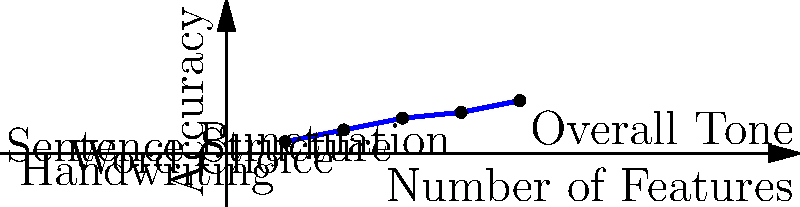As an aspiring indie author, you're developing a sentiment analysis model for handwritten book reviews. The graph shows the accuracy of your model as you add different features. Which feature, when added, results in the most significant improvement in accuracy, and what might this suggest about the importance of certain elements in handwritten reviews? To answer this question, we need to analyze the graph step-by-step:

1. The x-axis represents the number of features added to the sentiment analysis model.
2. The y-axis represents the accuracy of the model.
3. Each point on the graph represents a feature:
   (1, 0.2) - Handwriting
   (2, 0.4) - Word Choice
   (3, 0.6) - Sentence Structure
   (4, 0.7) - Punctuation
   (5, 0.9) - Overall Tone

4. To find the feature that results in the most significant improvement, we need to calculate the increase in accuracy between each point:
   Handwriting to Word Choice: 0.4 - 0.2 = 0.2
   Word Choice to Sentence Structure: 0.6 - 0.4 = 0.2
   Sentence Structure to Punctuation: 0.7 - 0.6 = 0.1
   Punctuation to Overall Tone: 0.9 - 0.7 = 0.2

5. The largest increase is 0.2, which occurs three times. However, the question asks for the most significant improvement, so we should consider which of these 0.2 increases is most impactful.

6. The increase from Handwriting to Word Choice (0.2 to 0.4) doubles the accuracy, making it the most significant improvement.

This suggests that word choice is a crucial element in determining the sentiment of handwritten book reviews. As an aspiring author, this implies that readers pay close attention to the specific words used in reviews, which can greatly influence their overall sentiment.
Answer: Word Choice; readers focus on specific language in reviews. 